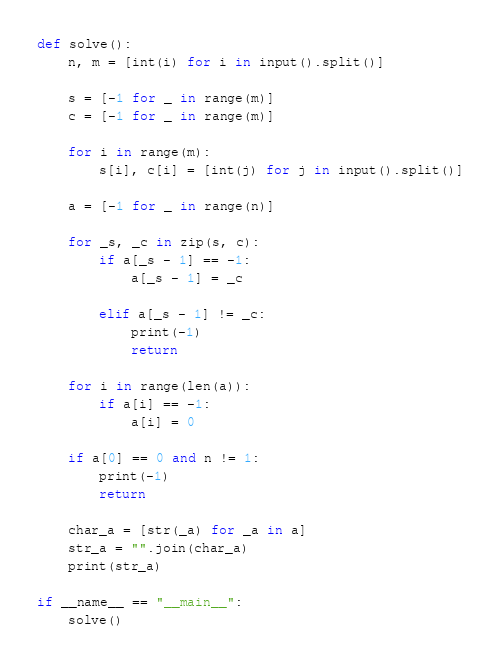<code> <loc_0><loc_0><loc_500><loc_500><_Python_>def solve():
    n, m = [int(i) for i in input().split()]

    s = [-1 for _ in range(m)]
    c = [-1 for _ in range(m)]

    for i in range(m):
        s[i], c[i] = [int(j) for j in input().split()]

    a = [-1 for _ in range(n)]

    for _s, _c in zip(s, c):
        if a[_s - 1] == -1:
            a[_s - 1] = _c

        elif a[_s - 1] != _c:
            print(-1)
            return

    for i in range(len(a)):
        if a[i] == -1:
            a[i] = 0
    
    if a[0] == 0 and n != 1:
        print(-1)
        return

    char_a = [str(_a) for _a in a]
    str_a = "".join(char_a)
    print(str_a)

if __name__ == "__main__":
    solve()
</code> 